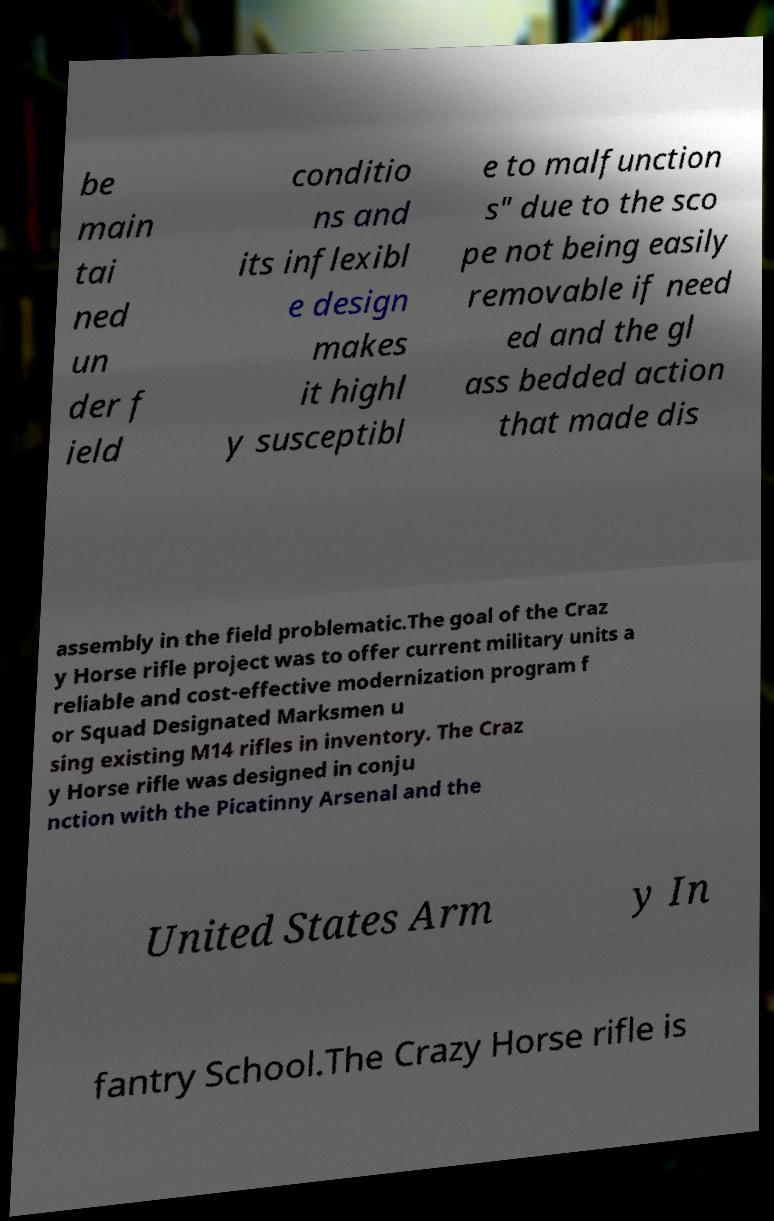What messages or text are displayed in this image? I need them in a readable, typed format. be main tai ned un der f ield conditio ns and its inflexibl e design makes it highl y susceptibl e to malfunction s" due to the sco pe not being easily removable if need ed and the gl ass bedded action that made dis assembly in the field problematic.The goal of the Craz y Horse rifle project was to offer current military units a reliable and cost-effective modernization program f or Squad Designated Marksmen u sing existing M14 rifles in inventory. The Craz y Horse rifle was designed in conju nction with the Picatinny Arsenal and the United States Arm y In fantry School.The Crazy Horse rifle is 